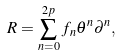<formula> <loc_0><loc_0><loc_500><loc_500>R = \sum _ { n = 0 } ^ { 2 p } f _ { n } \theta ^ { n } \partial ^ { n } ,</formula> 